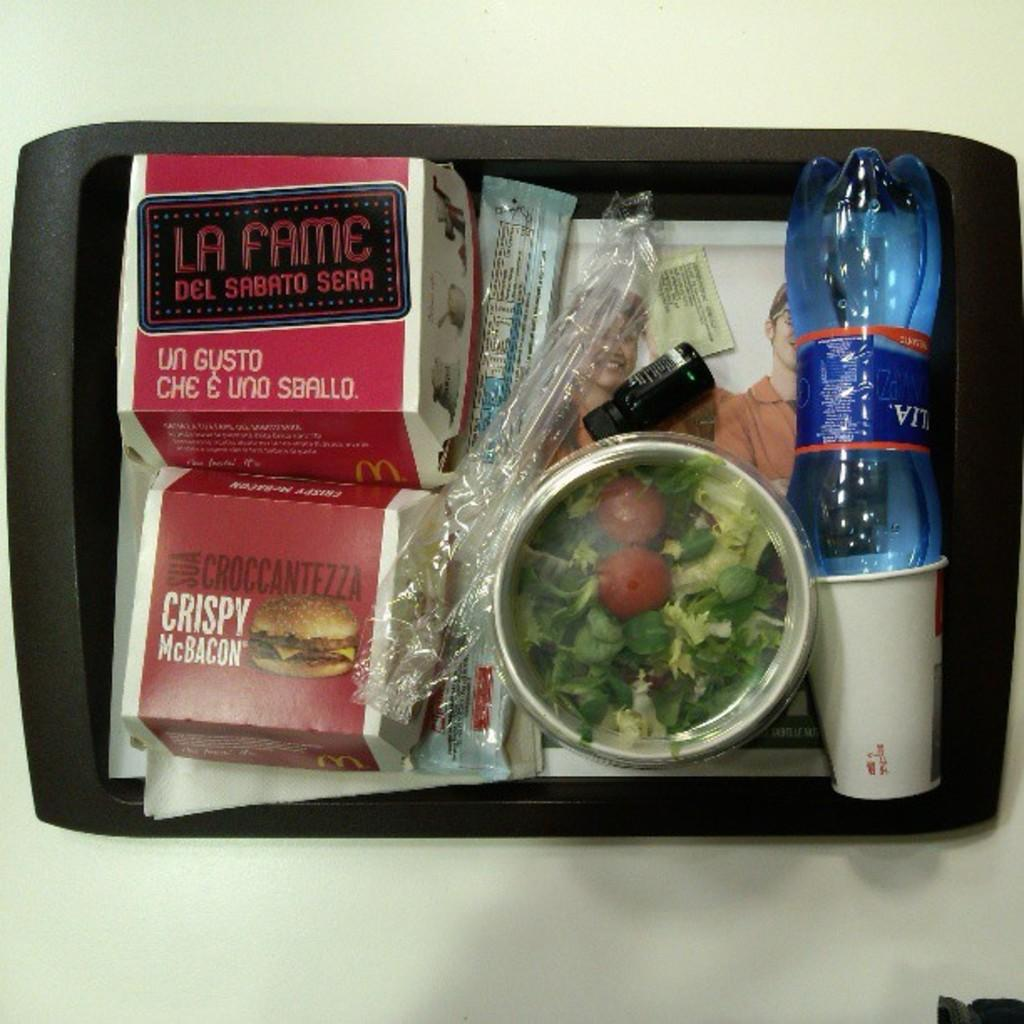<image>
Offer a succinct explanation of the picture presented. A tray of food that has a Crispy McBacon on the bottom left. 